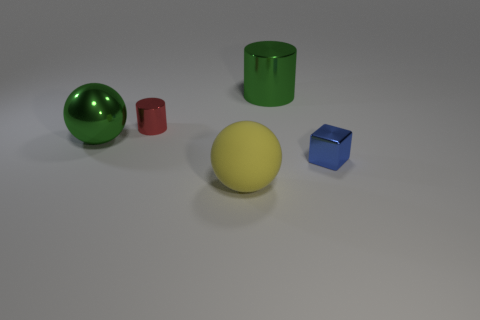Are there any large metallic things that have the same color as the shiny ball?
Provide a succinct answer. Yes. The ball that is the same color as the big cylinder is what size?
Your response must be concise. Large. There is a large thing behind the shiny cylinder left of the large metal object that is right of the big metal sphere; what color is it?
Offer a terse response. Green. What is the color of the large cylinder that is the same material as the tiny blue thing?
Your response must be concise. Green. What number of things are metallic objects that are to the left of the small red thing or brown shiny cylinders?
Give a very brief answer. 1. There is a sphere that is behind the blue thing; what is its size?
Provide a succinct answer. Large. Does the blue thing have the same size as the cylinder that is to the left of the large green cylinder?
Keep it short and to the point. Yes. What color is the metallic thing behind the small metallic object left of the large shiny cylinder?
Provide a succinct answer. Green. What number of other things are the same color as the big metallic cylinder?
Offer a very short reply. 1. The blue metal object is what size?
Your response must be concise. Small. 